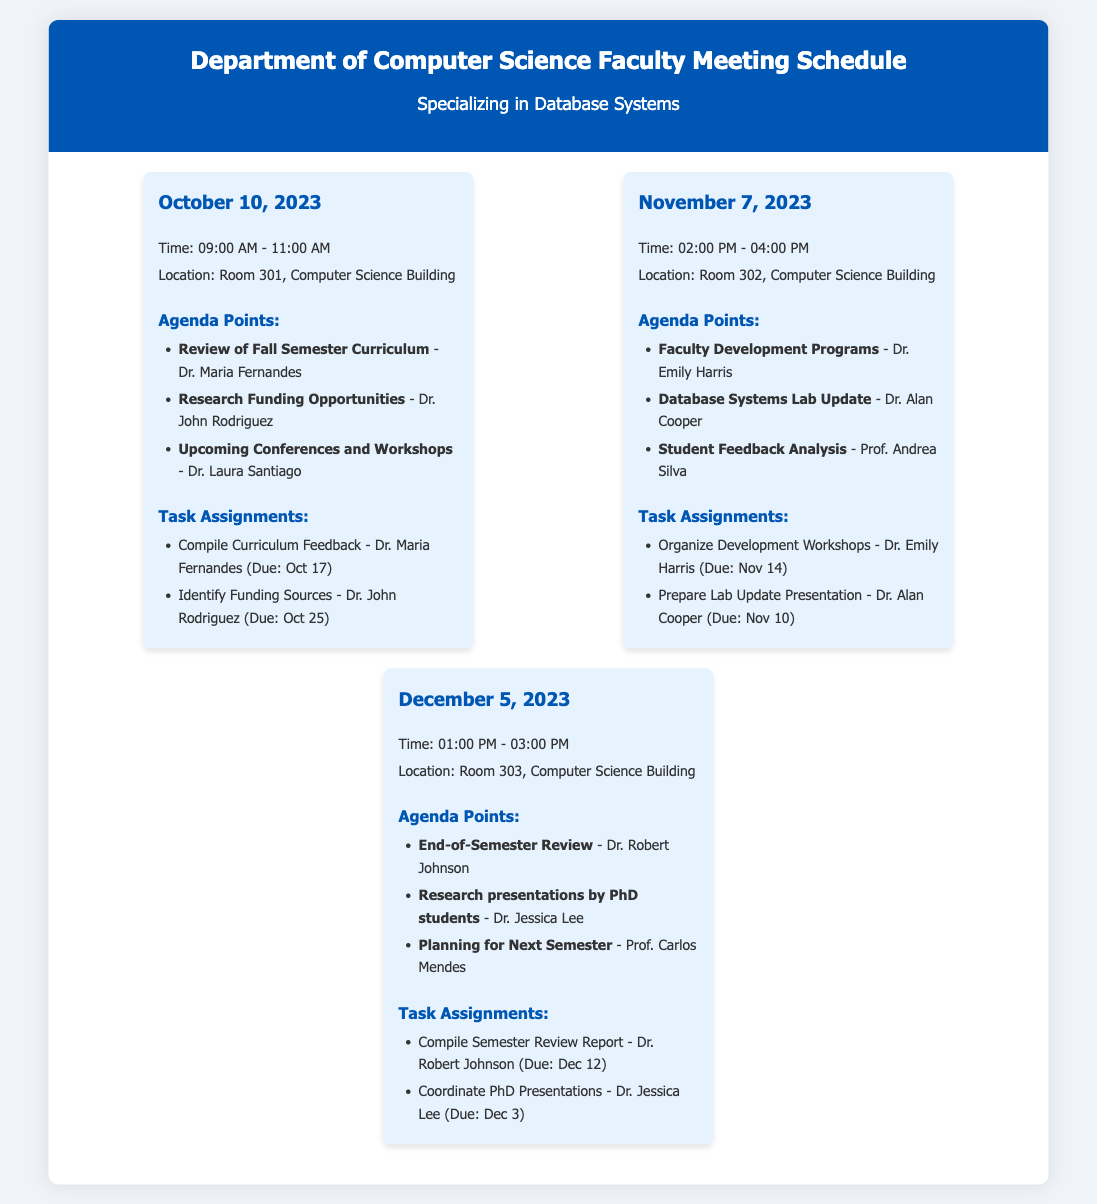What is the date of the first meeting? The first meeting is scheduled for October 10, 2023, as indicated in the document.
Answer: October 10, 2023 Who is responsible for organizing development workshops? Dr. Emily Harris is tasked with organizing the development workshops, as listed in the task assignments.
Answer: Dr. Emily Harris What is the due date for compiling the curriculum feedback? The document states that the due date for compiling the curriculum feedback is October 17, as assigned to Dr. Maria Fernandes.
Answer: October 17 How many agenda points are discussed in the December meeting? The December 5, 2023 meeting lists three agenda points, as outlined in the agenda section.
Answer: Three Which location hosts the November meeting? Room 302 in the Computer Science Building is specified for the November 7, 2023 meeting.
Answer: Room 302 What is the time frame for the meeting on December 5, 2023? The meeting on December 5, 2023 is scheduled from 01:00 PM to 03:00 PM, as mentioned in the document.
Answer: 01:00 PM - 03:00 PM Which professor will present research findings in the December meeting? Dr. Jessica Lee is mentioned as the one who will lead the research presentations by PhD students.
Answer: Dr. Jessica Lee What is the focus of the agenda point presented by Dr. Alan Cooper in November? The agenda point by Dr. Alan Cooper is related to the Database Systems Lab Update, which is specified in the document.
Answer: Database Systems Lab Update 